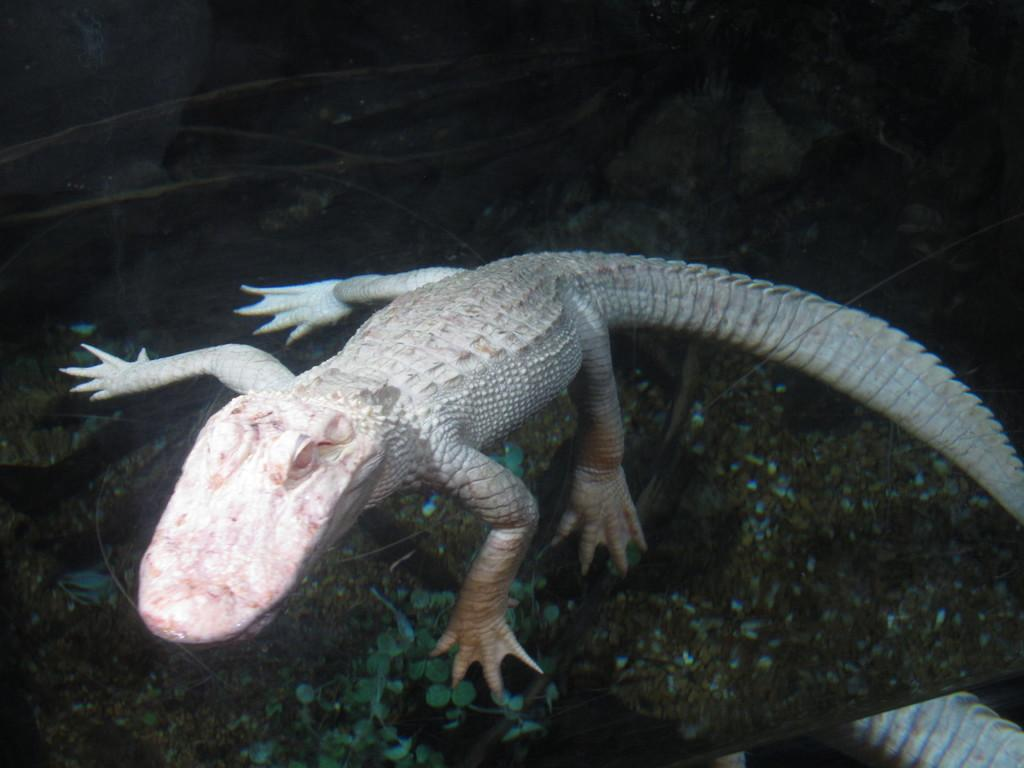What type of animal is in the image? There is a reptile in the image. What else can be seen in the image besides the reptile? There are leaves in the image. How many trucks are visible in the image? There are no trucks present in the image. What type of legs does the reptile have in the image? The image does not show the reptile's legs, so it cannot be determined from the image. 